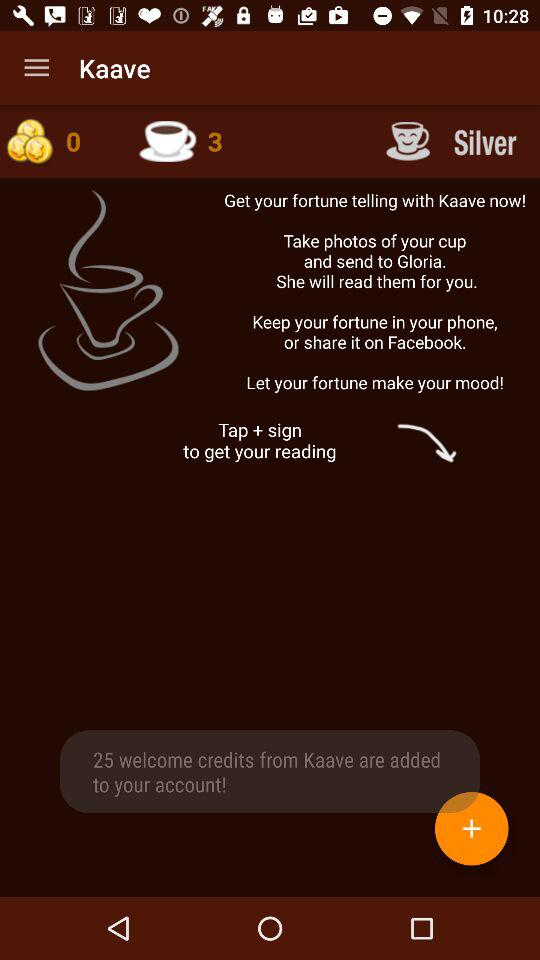When was the last fortune told?
When the provided information is insufficient, respond with <no answer>. <no answer> 